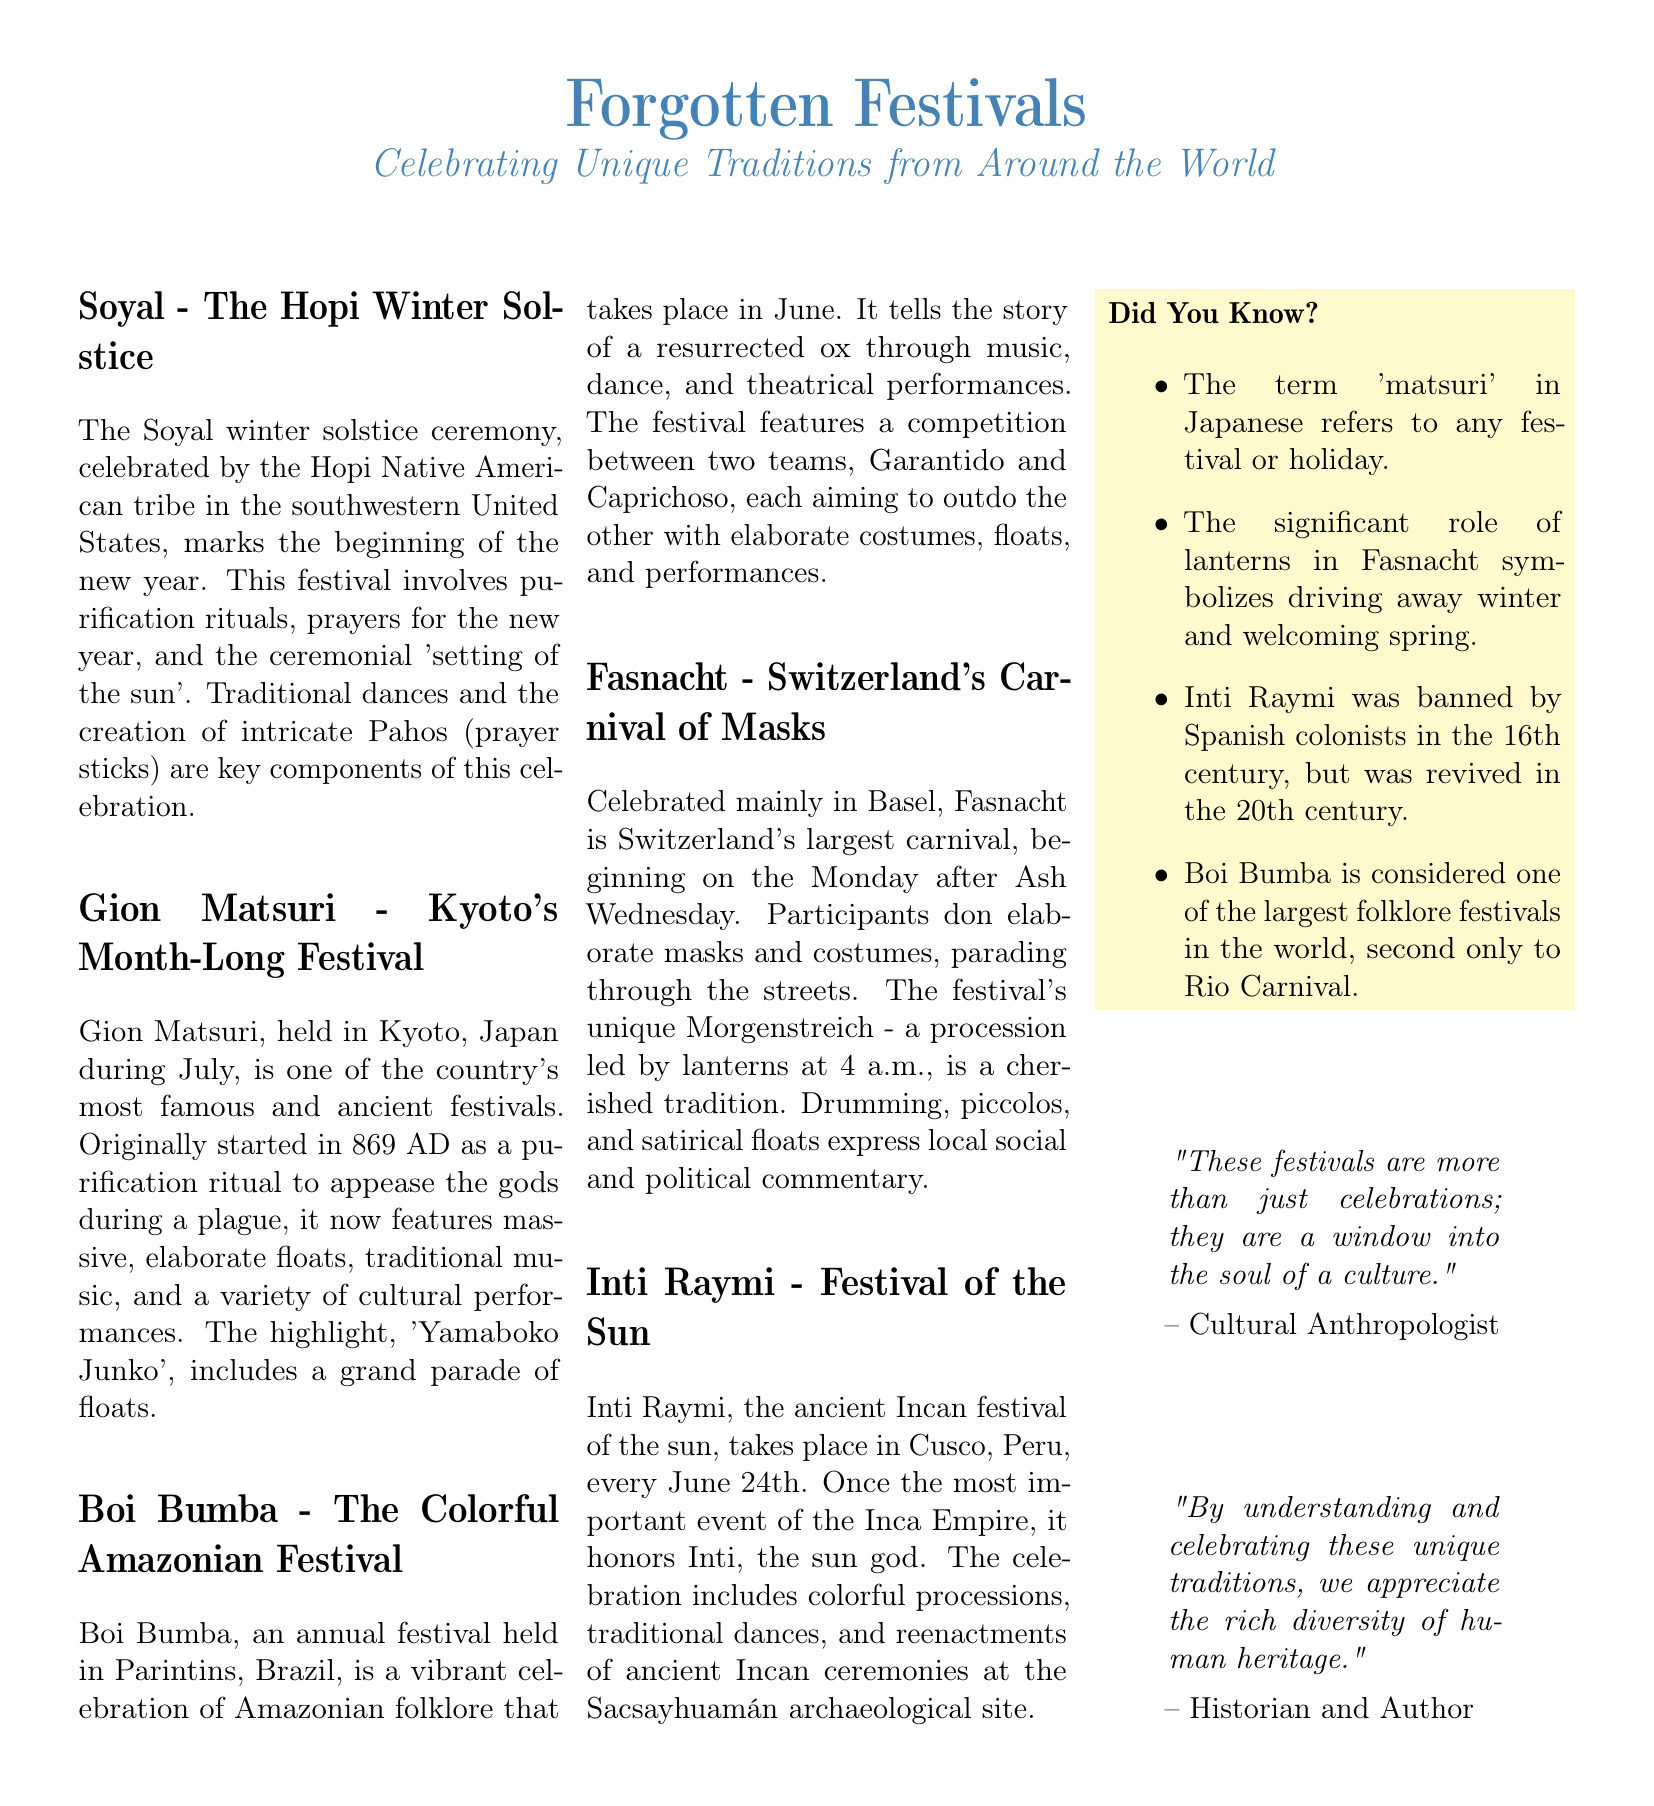What is the Hopi winter solstice ceremony called? The festival celebrated by the Hopi tribe to mark the winter solstice is referred to as Soyal.
Answer: Soyal When is the Boi Bumba festival held? The Boi Bumba festival takes place annually in June.
Answer: June What is the main feature of the Gion Matsuri festival? The highlight of the Gion Matsuri includes a grand parade of floats called 'Yamaboko Junko'.
Answer: Yamaboko Junko Which culture celebrates the Inti Raymi festival? The Inti Raymi festival is an ancient Incan celebration honoring the sun god.
Answer: Incan How is Fasnacht celebrated? Fasnacht is celebrated with elaborate masks and costumes during a procession through the streets.
Answer: Masks and costumes What significant role do lanterns play in Fasnacht? Lanterns symbolize driving away winter and welcoming spring during Fasnacht.
Answer: Driving away winter What year did Gion Matsuri start? The Gion Matsuri festival originated in 869 AD.
Answer: 869 AD How many teams compete in the Boi Bumba festival? There are two teams that compete in the Boi Bumba festival.
Answer: Two teams What is the purpose of the purification rituals in Soyal? The purification rituals in Soyal are prayers for the new year, marking a fresh beginning.
Answer: Prayers for the new year 